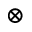<formula> <loc_0><loc_0><loc_500><loc_500>\otimes</formula> 